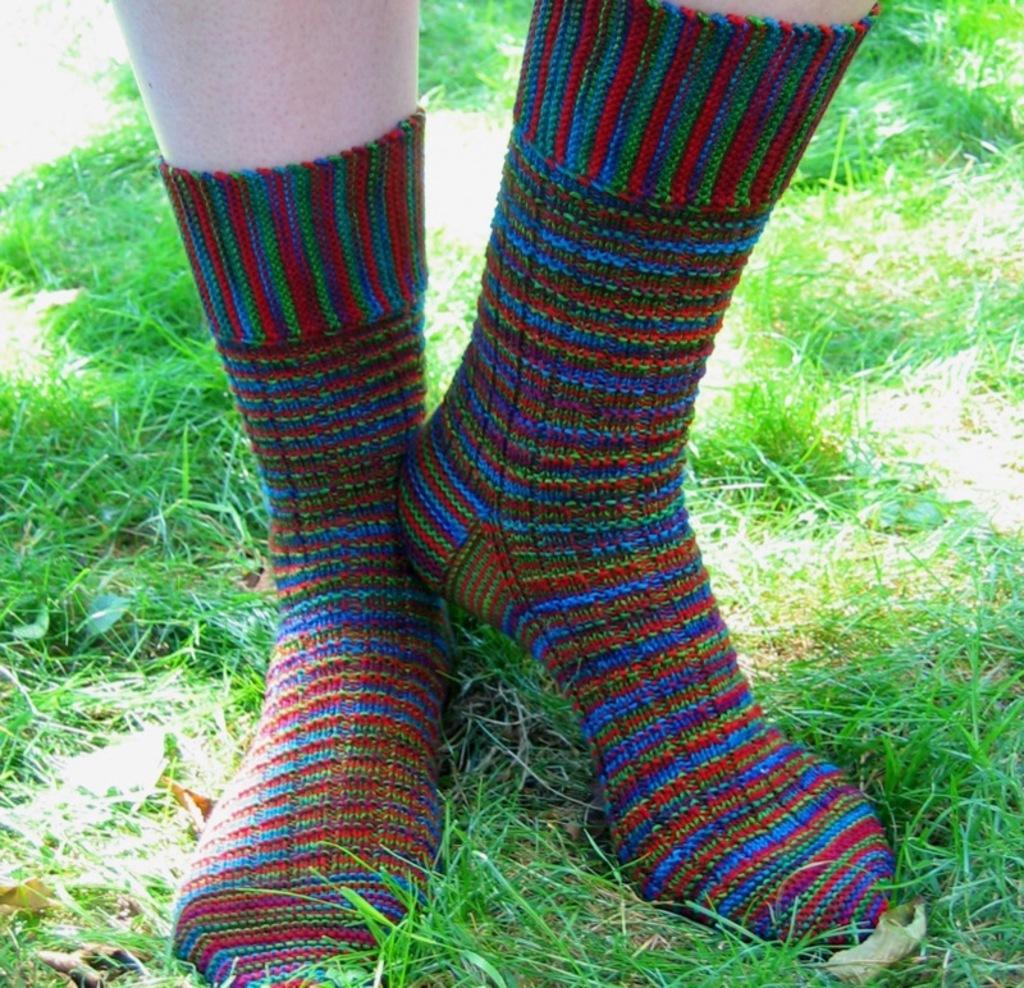Could you give a brief overview of what you see in this image? There is a person wearing shoes on the grass on the ground. In the background, there is grass on the ground. 